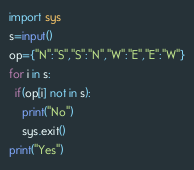<code> <loc_0><loc_0><loc_500><loc_500><_Python_>import sys
s=input()
op={"N":"S","S":"N","W":"E","E":"W"}
for i in s:
  if(op[i] not in s):
    print("No")
    sys.exit()
print("Yes")</code> 